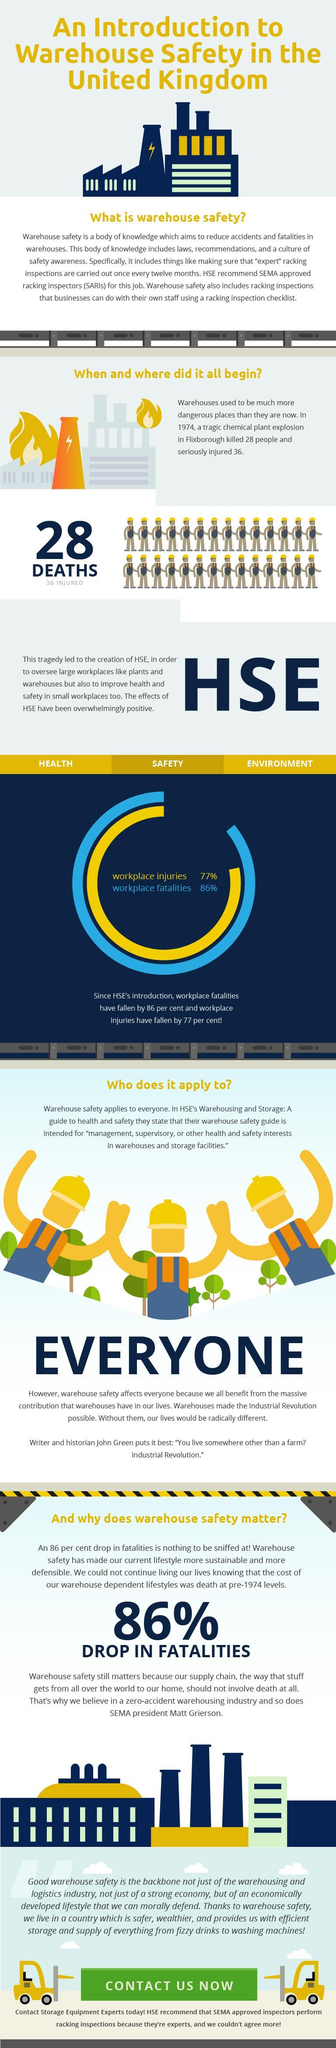How many rows of people are in this infographic?
Answer the question with a short phrase. 2 What is the name of the disaster? Flixborough 